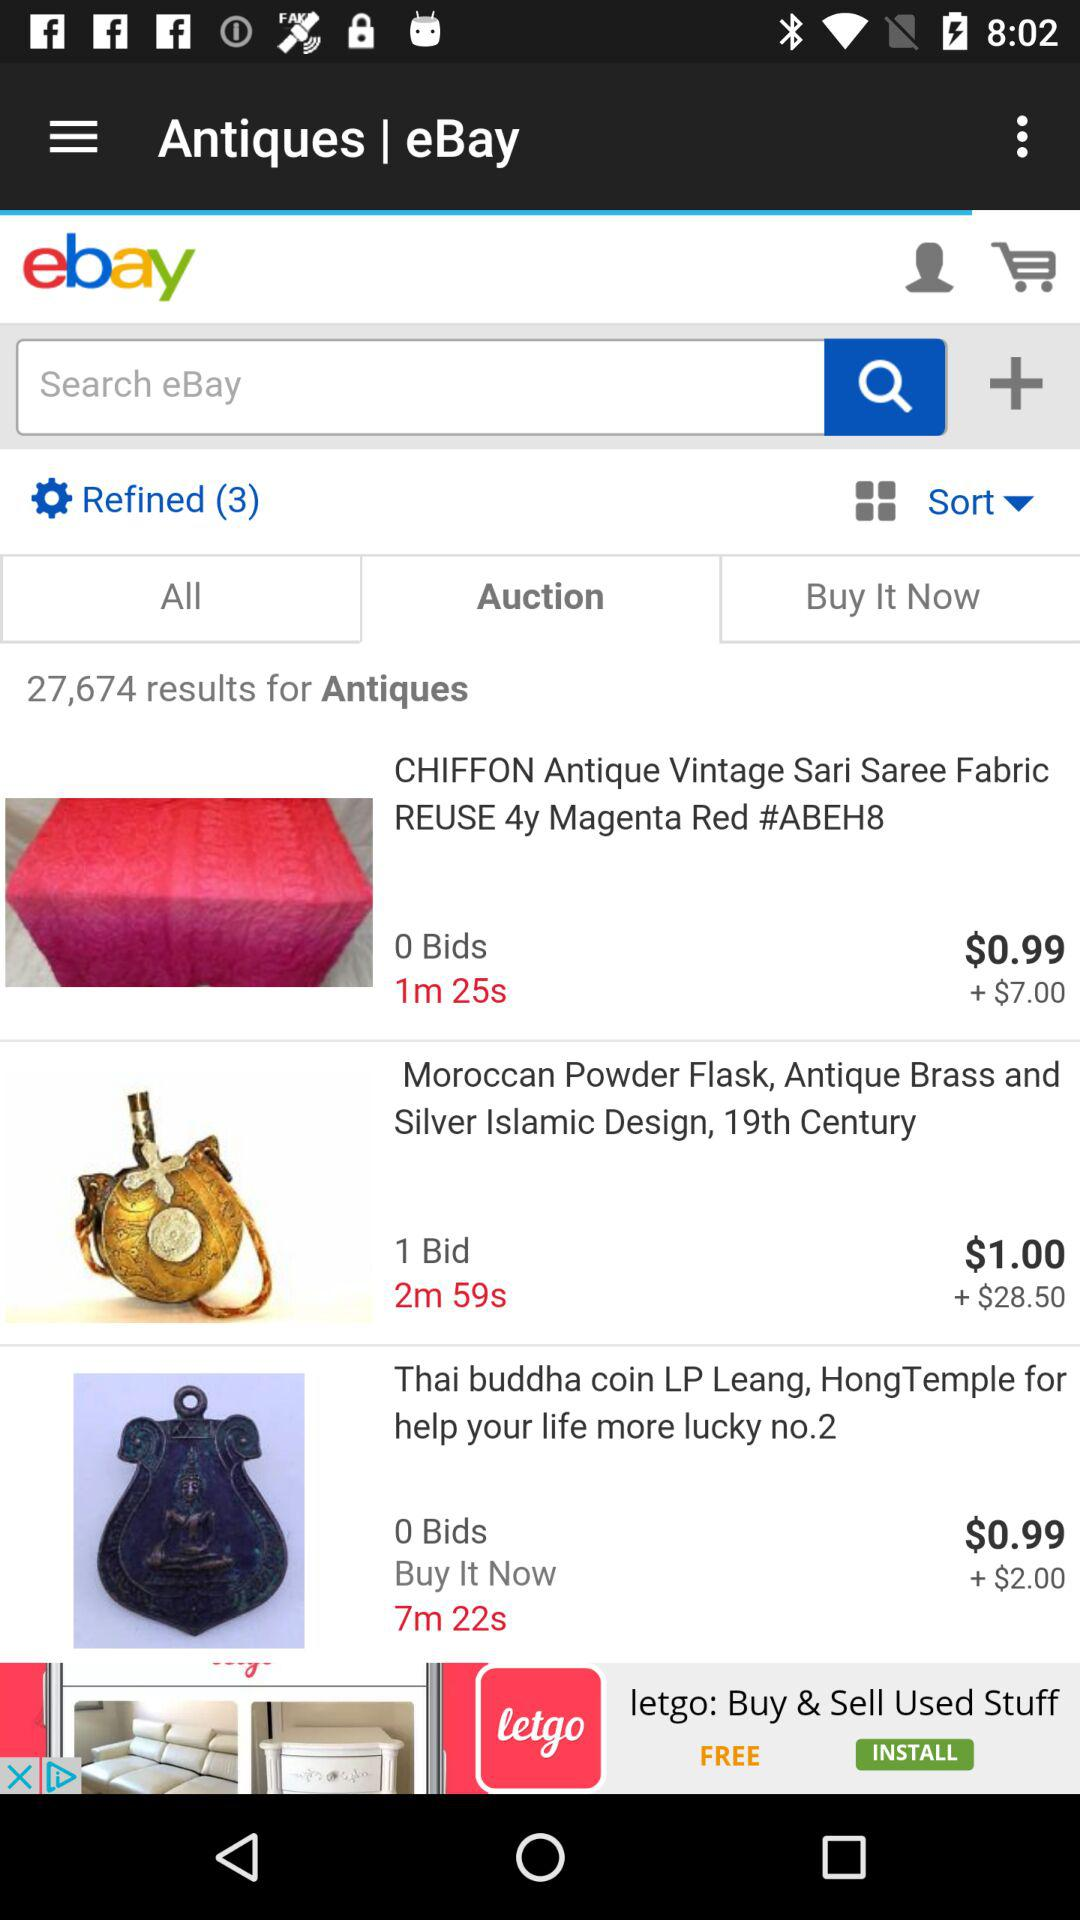How many more bids does the first item have than the second item?
Answer the question using a single word or phrase. 1 